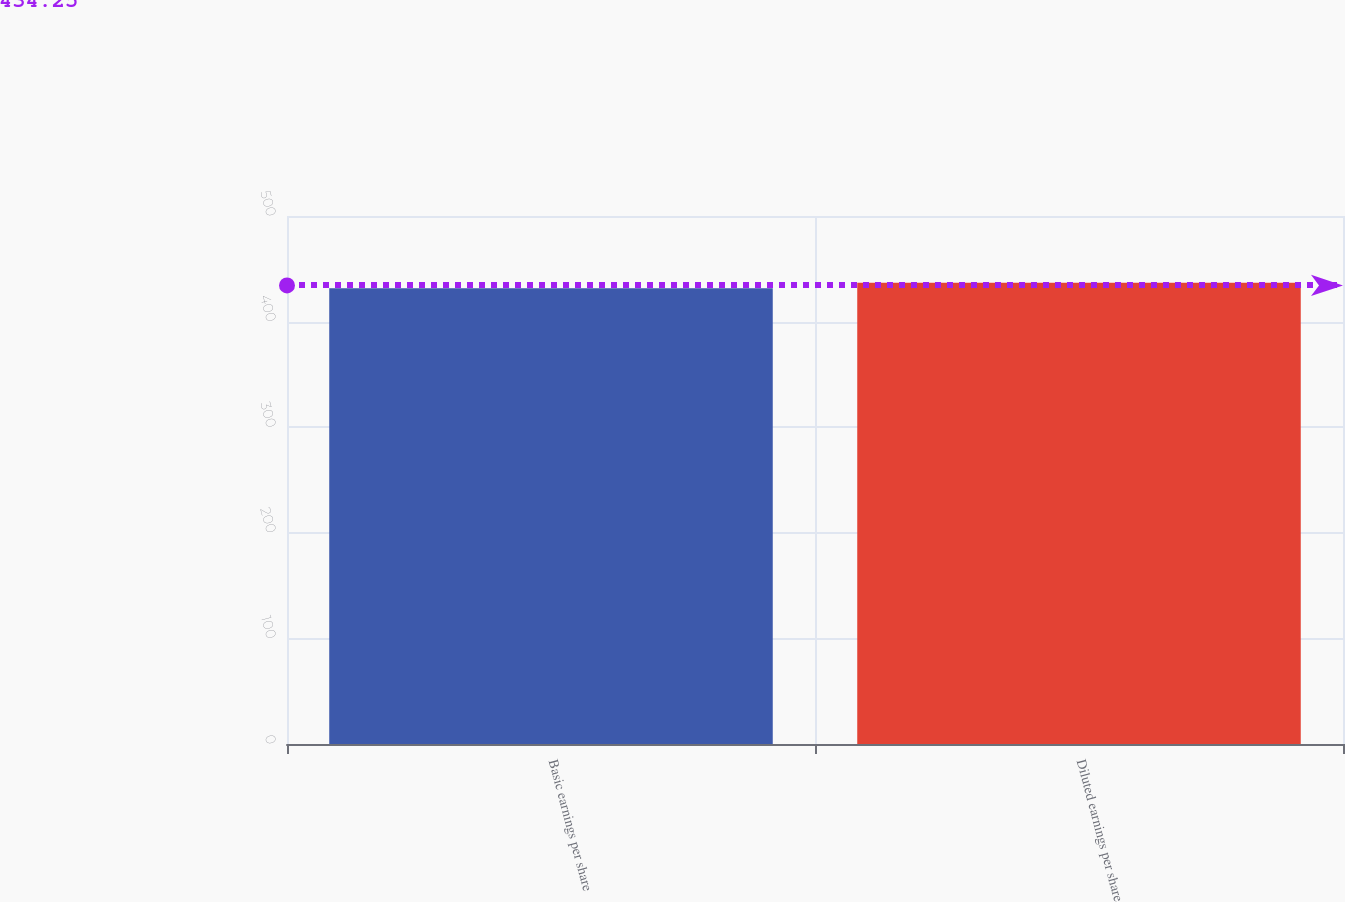<chart> <loc_0><loc_0><loc_500><loc_500><bar_chart><fcel>Basic earnings per share<fcel>Diluted earnings per share<nl><fcel>431.6<fcel>436.9<nl></chart> 